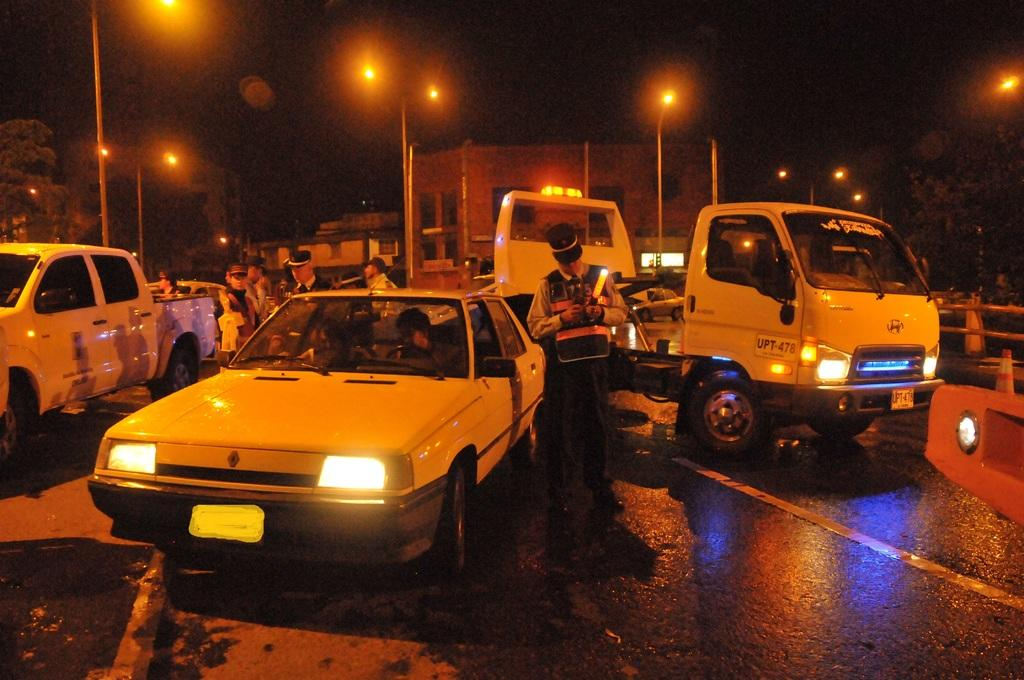What can be seen on the road in the image? There are vehicles and people on the road in the image. What is visible in the background of the image? There are lights, trees, and buildings in the background. Can you identify any objects used for traffic control in the image? Yes, traffic cones are visible in the image. What type of growth can be seen on the yam in the image? There is no yam present in the image, so it is not possible to determine any growth on it. Can you describe the cord used to connect the lights in the image? There is no cord visible in the image; only the lights themselves are present. 